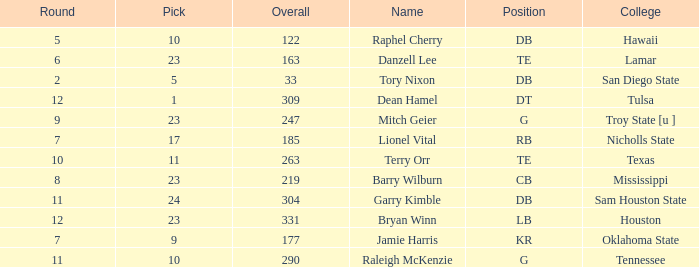Write the full table. {'header': ['Round', 'Pick', 'Overall', 'Name', 'Position', 'College'], 'rows': [['5', '10', '122', 'Raphel Cherry', 'DB', 'Hawaii'], ['6', '23', '163', 'Danzell Lee', 'TE', 'Lamar'], ['2', '5', '33', 'Tory Nixon', 'DB', 'San Diego State'], ['12', '1', '309', 'Dean Hamel', 'DT', 'Tulsa'], ['9', '23', '247', 'Mitch Geier', 'G', 'Troy State [u ]'], ['7', '17', '185', 'Lionel Vital', 'RB', 'Nicholls State'], ['10', '11', '263', 'Terry Orr', 'TE', 'Texas'], ['8', '23', '219', 'Barry Wilburn', 'CB', 'Mississippi'], ['11', '24', '304', 'Garry Kimble', 'DB', 'Sam Houston State'], ['12', '23', '331', 'Bryan Winn', 'LB', 'Houston'], ['7', '9', '177', 'Jamie Harris', 'KR', 'Oklahoma State'], ['11', '10', '290', 'Raleigh McKenzie', 'G', 'Tennessee']]} Which Round is the highest one that has a Pick smaller than 10, and a Name of tory nixon? 2.0. 